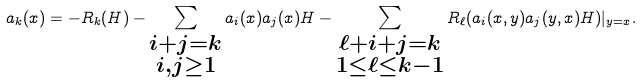Convert formula to latex. <formula><loc_0><loc_0><loc_500><loc_500>a _ { k } ( x ) = - R _ { k } ( H ) - \sum _ { \substack { i + j = k \\ i , j \geq 1 } } a _ { i } ( x ) a _ { j } ( x ) H - \sum _ { \substack { \ell + i + j = k \\ 1 \leq \ell \leq k - 1 } } R _ { \ell } ( a _ { i } ( x , y ) a _ { j } ( y , x ) H ) | _ { y = x } .</formula> 